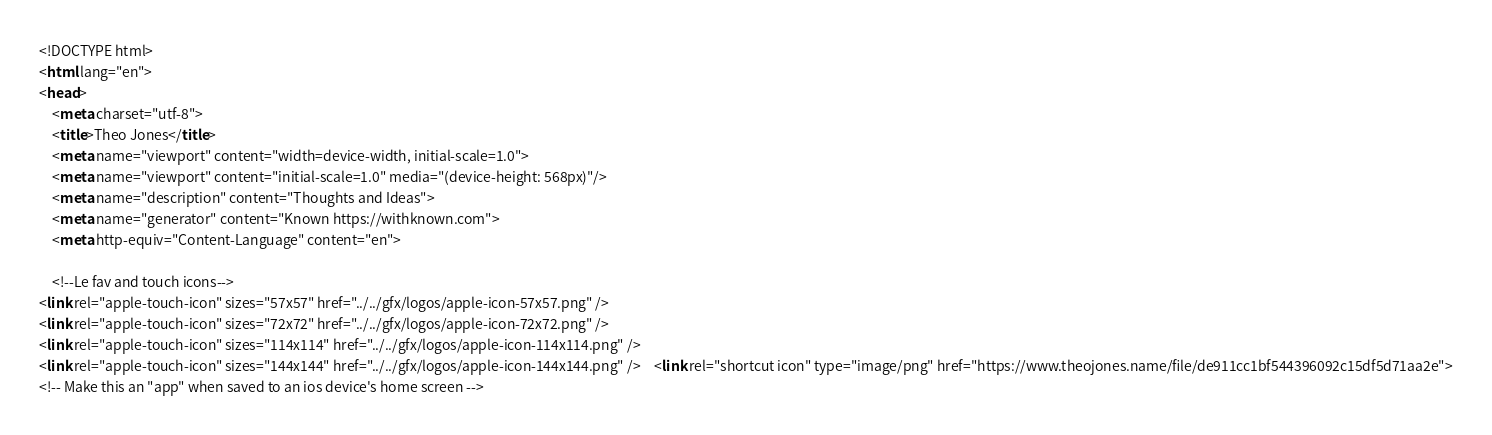<code> <loc_0><loc_0><loc_500><loc_500><_HTML_><!DOCTYPE html>
<html lang="en">
<head>
    <meta charset="utf-8">
    <title>Theo Jones</title>
    <meta name="viewport" content="width=device-width, initial-scale=1.0">
    <meta name="viewport" content="initial-scale=1.0" media="(device-height: 568px)"/>
    <meta name="description" content="Thoughts and Ideas">
    <meta name="generator" content="Known https://withknown.com">
    <meta http-equiv="Content-Language" content="en">

    <!--Le fav and touch icons-->
<link rel="apple-touch-icon" sizes="57x57" href="../../gfx/logos/apple-icon-57x57.png" />
<link rel="apple-touch-icon" sizes="72x72" href="../../gfx/logos/apple-icon-72x72.png" />
<link rel="apple-touch-icon" sizes="114x114" href="../../gfx/logos/apple-icon-114x114.png" />
<link rel="apple-touch-icon" sizes="144x144" href="../../gfx/logos/apple-icon-144x144.png" />    <link rel="shortcut icon" type="image/png" href="https://www.theojones.name/file/de911cc1bf544396092c15df5d71aa2e">
<!-- Make this an "app" when saved to an ios device's home screen --></code> 